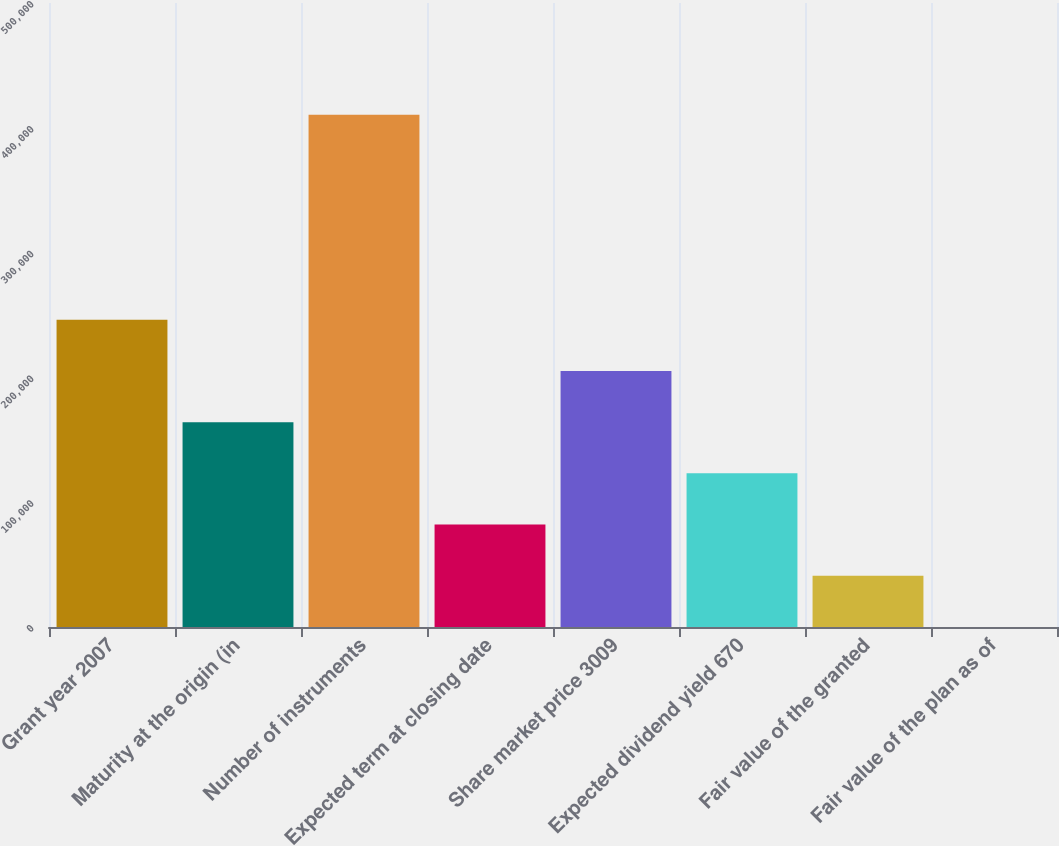<chart> <loc_0><loc_0><loc_500><loc_500><bar_chart><fcel>Grant year 2007<fcel>Maturity at the origin (in<fcel>Number of instruments<fcel>Expected term at closing date<fcel>Share market price 3009<fcel>Expected dividend yield 670<fcel>Fair value of the granted<fcel>Fair value of the plan as of<nl><fcel>246240<fcel>164161<fcel>410400<fcel>82080.7<fcel>205200<fcel>123121<fcel>41040.8<fcel>0.9<nl></chart> 